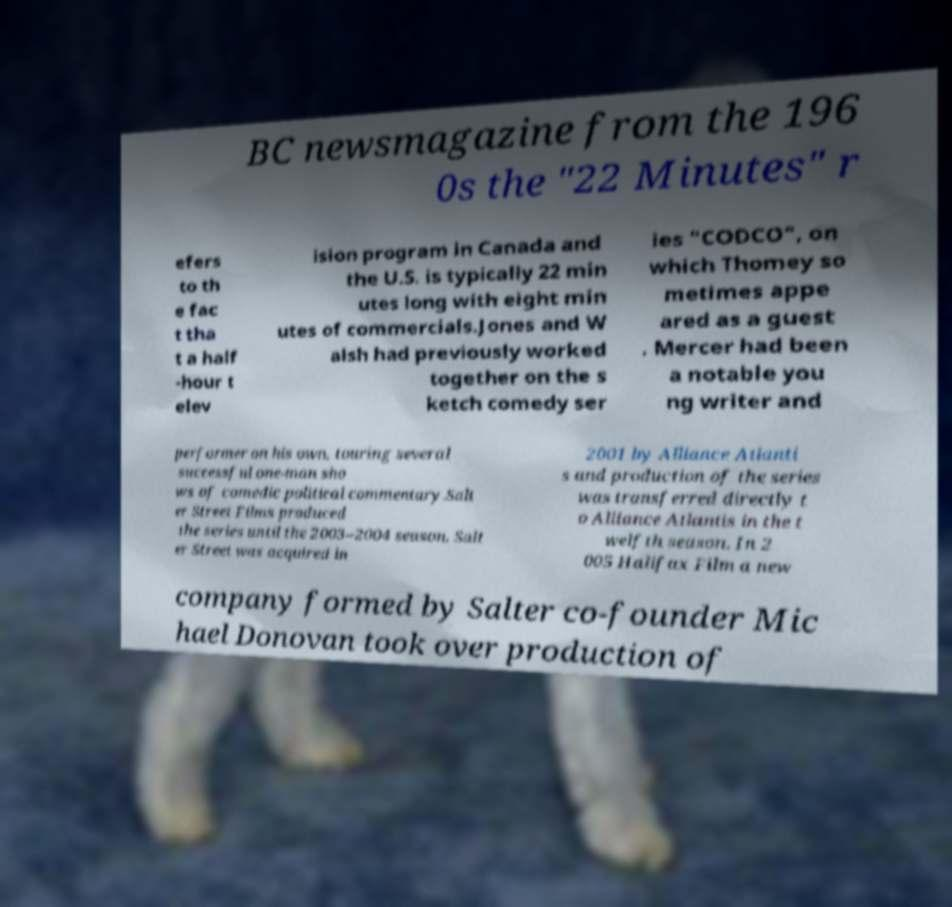Could you assist in decoding the text presented in this image and type it out clearly? BC newsmagazine from the 196 0s the "22 Minutes" r efers to th e fac t tha t a half -hour t elev ision program in Canada and the U.S. is typically 22 min utes long with eight min utes of commercials.Jones and W alsh had previously worked together on the s ketch comedy ser ies "CODCO", on which Thomey so metimes appe ared as a guest . Mercer had been a notable you ng writer and performer on his own, touring several successful one-man sho ws of comedic political commentary.Salt er Street Films produced the series until the 2003–2004 season. Salt er Street was acquired in 2001 by Alliance Atlanti s and production of the series was transferred directly t o Alliance Atlantis in the t welfth season. In 2 005 Halifax Film a new company formed by Salter co-founder Mic hael Donovan took over production of 